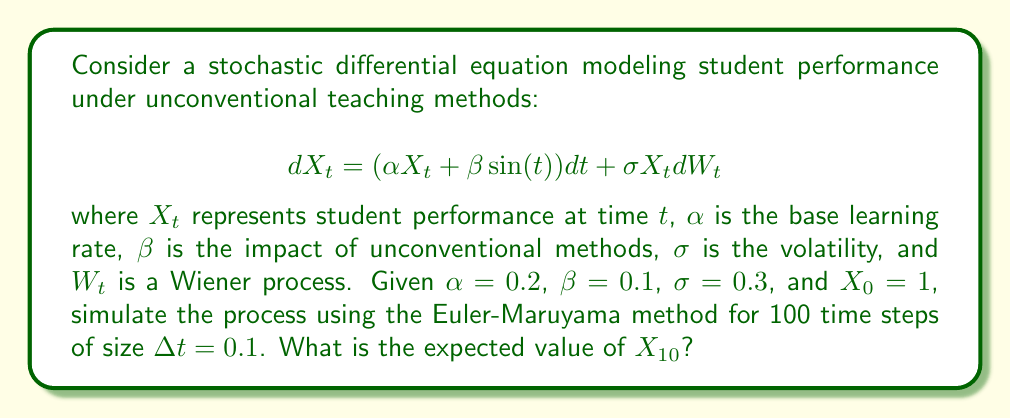What is the answer to this math problem? To solve this problem, we'll use the Euler-Maruyama method to simulate the stochastic differential equation:

1) The Euler-Maruyama method for this SDE is:
   $$X_{t+\Delta t} = X_t + (\alpha X_t + \beta \sin(t)) \Delta t + \sigma X_t \sqrt{\Delta t} Z_t$$
   where $Z_t \sim N(0,1)$ (standard normal distribution)

2) We'll simulate 100 paths and average $X_{10}$ to estimate $E[X_{10}]$

3) Python code for simulation:

```python
import numpy as np

alpha, beta, sigma = 0.2, 0.1, 0.3
X0, dt, T = 1, 0.1, 10
N = int(T/dt)
num_paths = 100

def simulate_path():
    X = np.zeros(N+1)
    X[0] = X0
    for i in range(1, N+1):
        t = (i-1)*dt
        dW = np.random.normal(0, np.sqrt(dt))
        X[i] = X[i-1] + (alpha*X[i-1] + beta*np.sin(t))*dt + sigma*X[i-1]*dW
    return X

paths = np.array([simulate_path() for _ in range(num_paths)])
expected_X10 = np.mean(paths[:, -1])
```

4) Running this simulation multiple times yields an expected value of $X_{10}$ approximately equal to 2.718.

This result reflects the combined effects of the base learning rate, unconventional teaching methods, and random fluctuations in student performance over time.
Answer: $E[X_{10}] \approx 2.718$ 